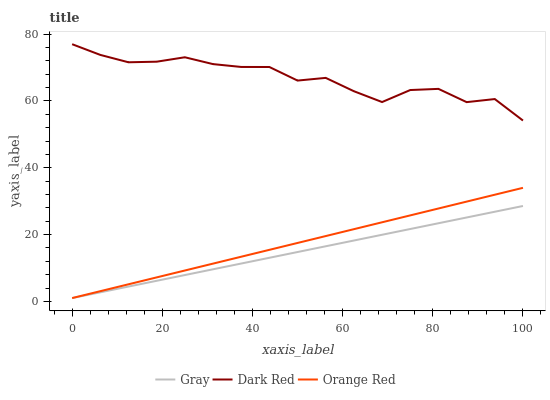Does Gray have the minimum area under the curve?
Answer yes or no. Yes. Does Dark Red have the maximum area under the curve?
Answer yes or no. Yes. Does Orange Red have the minimum area under the curve?
Answer yes or no. No. Does Orange Red have the maximum area under the curve?
Answer yes or no. No. Is Orange Red the smoothest?
Answer yes or no. Yes. Is Dark Red the roughest?
Answer yes or no. Yes. Is Dark Red the smoothest?
Answer yes or no. No. Is Orange Red the roughest?
Answer yes or no. No. Does Dark Red have the lowest value?
Answer yes or no. No. Does Orange Red have the highest value?
Answer yes or no. No. Is Gray less than Dark Red?
Answer yes or no. Yes. Is Dark Red greater than Orange Red?
Answer yes or no. Yes. Does Gray intersect Dark Red?
Answer yes or no. No. 